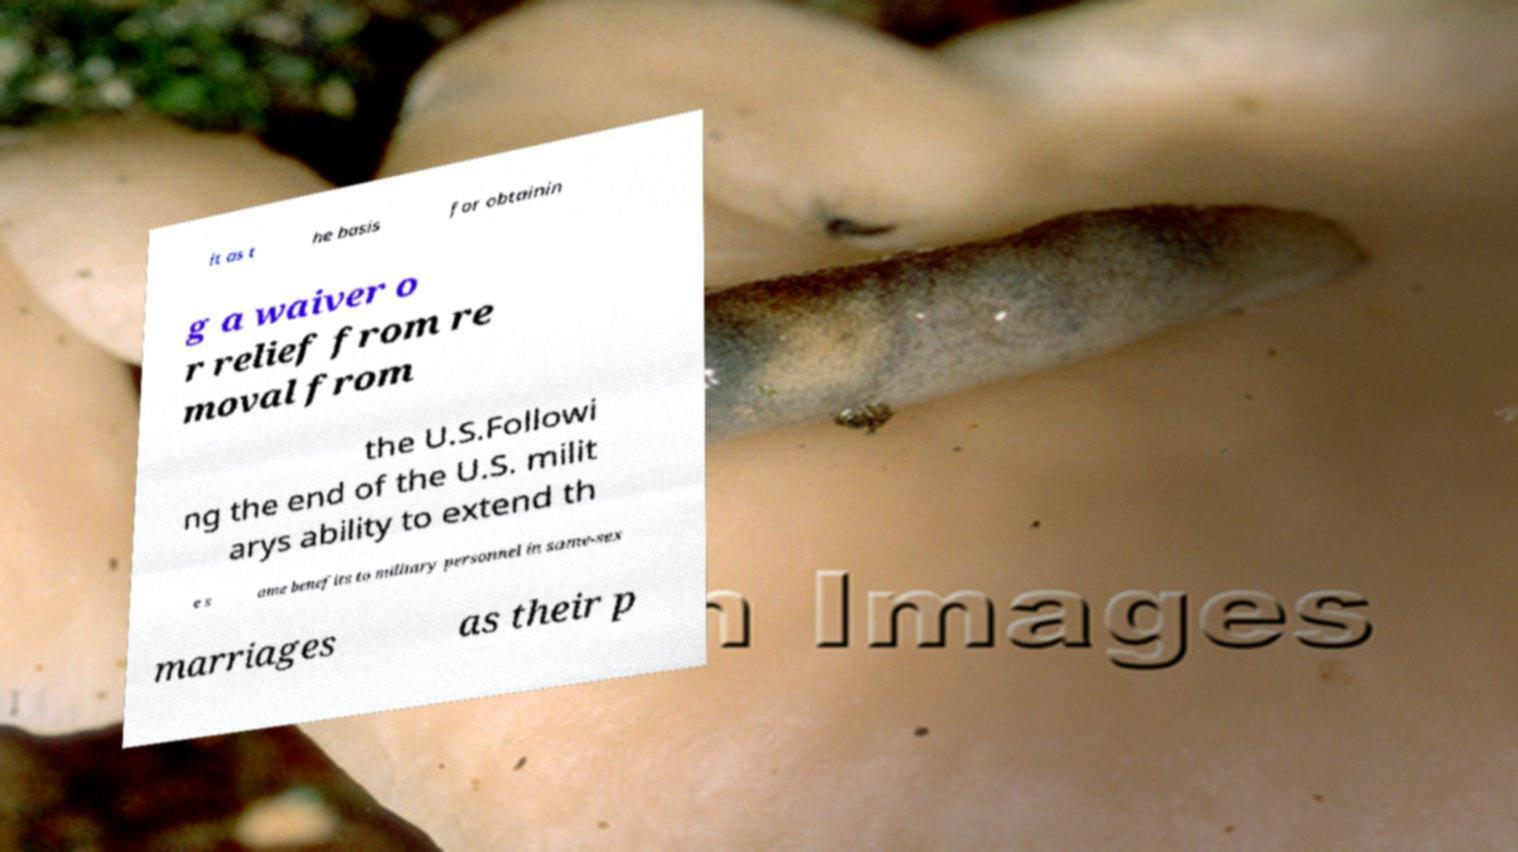What messages or text are displayed in this image? I need them in a readable, typed format. it as t he basis for obtainin g a waiver o r relief from re moval from the U.S.Followi ng the end of the U.S. milit arys ability to extend th e s ame benefits to military personnel in same-sex marriages as their p 